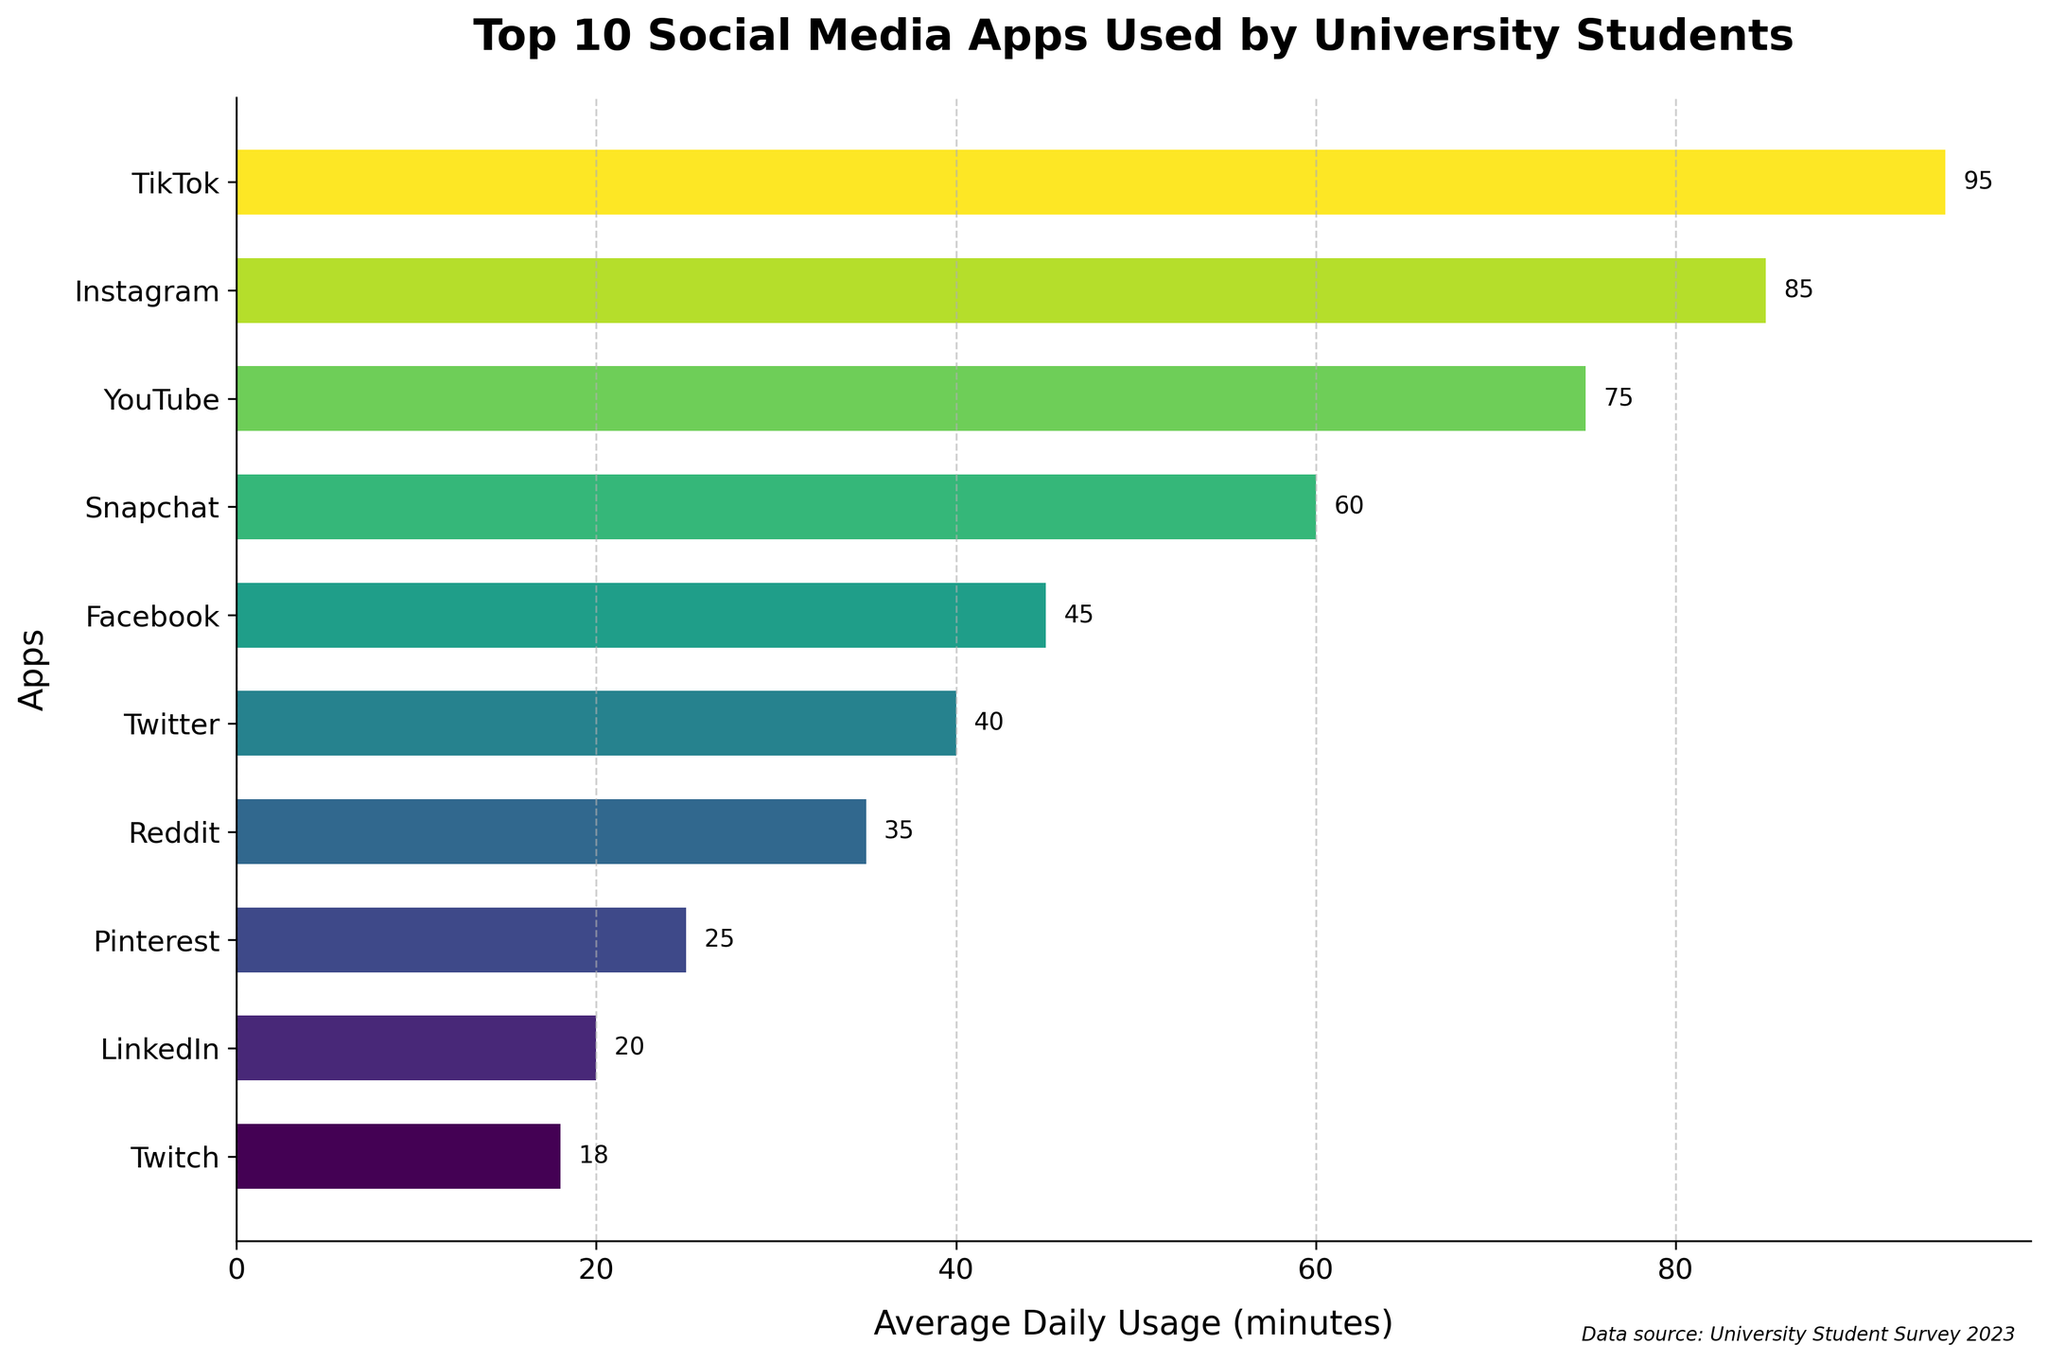Which social media app has the highest average daily usage? From the chart, TikTok has the longest bar, indicating the highest average daily usage.
Answer: TikTok Which app is used for an average of 60 minutes daily? From the label on the bar, Snapchat has an average daily usage of 60 minutes.
Answer: Snapchat How much more time do students spend on Instagram compared to Twitter? Instagram's average daily usage is 85 minutes and Twitter's is 40 minutes. The difference is 85 - 40.
Answer: 45 minutes How many apps have an average daily usage greater than 50 minutes? Visually identify the bars longer than 50 minutes. These are TikTok, Instagram, YouTube, and Snapchat. There are 4 apps in total.
Answer: 4 What is the combined average daily usage of YouTube and Facebook? YouTube’s average daily usage is 75 minutes, and Facebook’s is 45 minutes. The combined usage is 75 + 45.
Answer: 120 minutes Rank Snapchat and LinkedIn by their average daily usage. Snapchat has 60 minutes and LinkedIn has 20 minutes. Therefore, Snapchat ranks higher than LinkedIn.
Answer: Snapchat > LinkedIn Which app is used less daily, Pinterest or Reddit? From the chart, Pinterest has 25 minutes and Reddit has 35 minutes. Pinterest is used less daily.
Answer: Pinterest Name all apps with an average daily usage below 30 minutes. The apps with bars shorter than 30 minutes are Pinterest (25), LinkedIn (20), and Twitch (18).
Answer: Pinterest, LinkedIn, Twitch What is the difference in average daily usage between the most used app and the least used app in the top 10? The most used app is TikTok (95 minutes) and the least used in the top 10 is Twitch (18 minutes). The difference is 95 - 18.
Answer: 77 minutes Compare the average daily usage of Snapchat and Facebook, which one has a higher usage? By how much? Snapchat has 60 minutes, and Facebook has 45 minutes. Snapchat has a higher usage by 15 minutes (60 - 45).
Answer: Snapchat by 15 minutes 